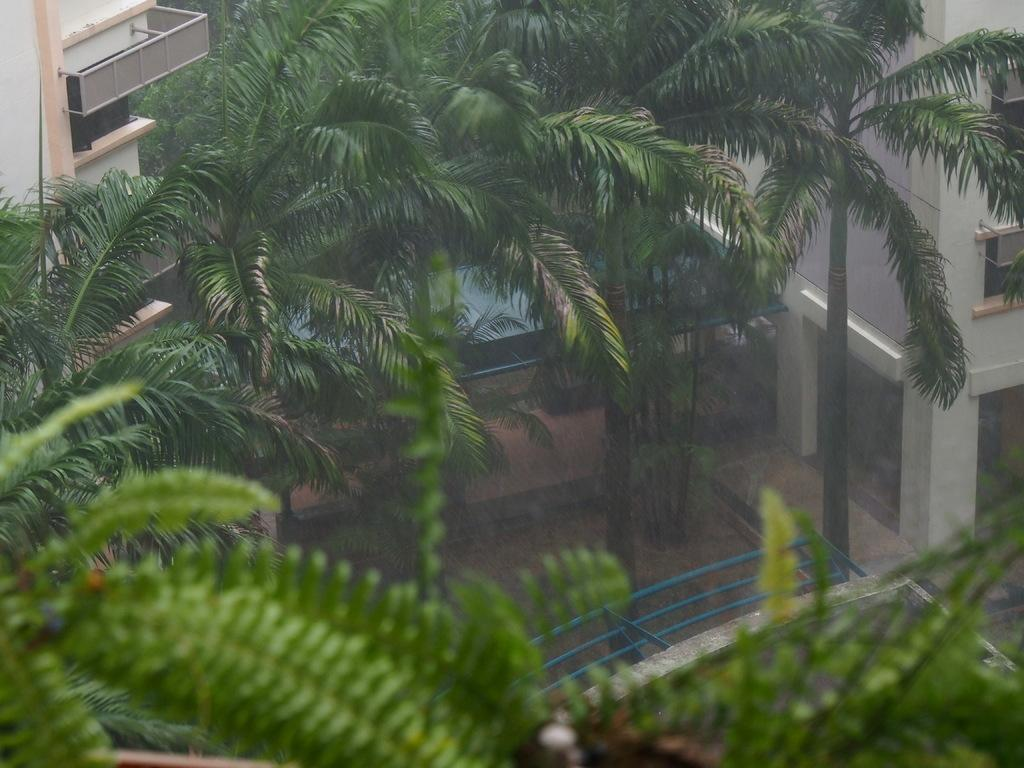What type of vegetation can be seen in the image? There are trees in the image. What is the color of the trees? The trees are green in color. What can be seen in the background of the image? There are buildings in the background of the image. What colors are the buildings? The buildings are in cream and white colors. What type of bread can be seen in the image? There is no bread present in the image. What kind of toys are visible in the image? There are no toys visible in the image. 